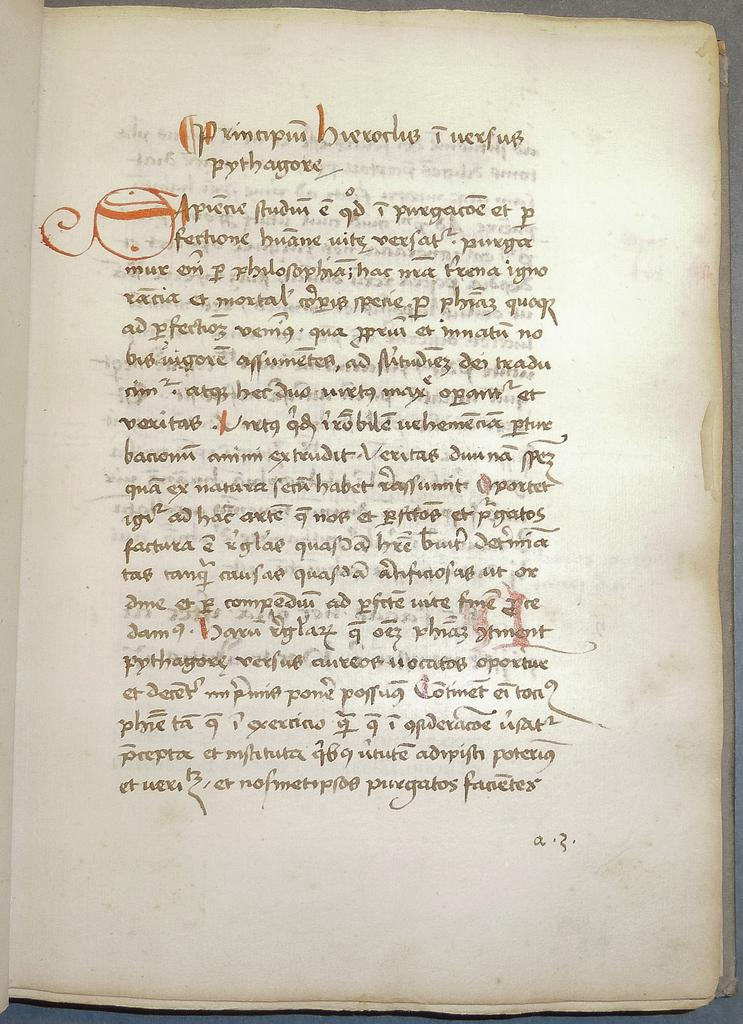<image>
Create a compact narrative representing the image presented. A book is opened to an ornate page with a letter A on the lower right corner of the page. 